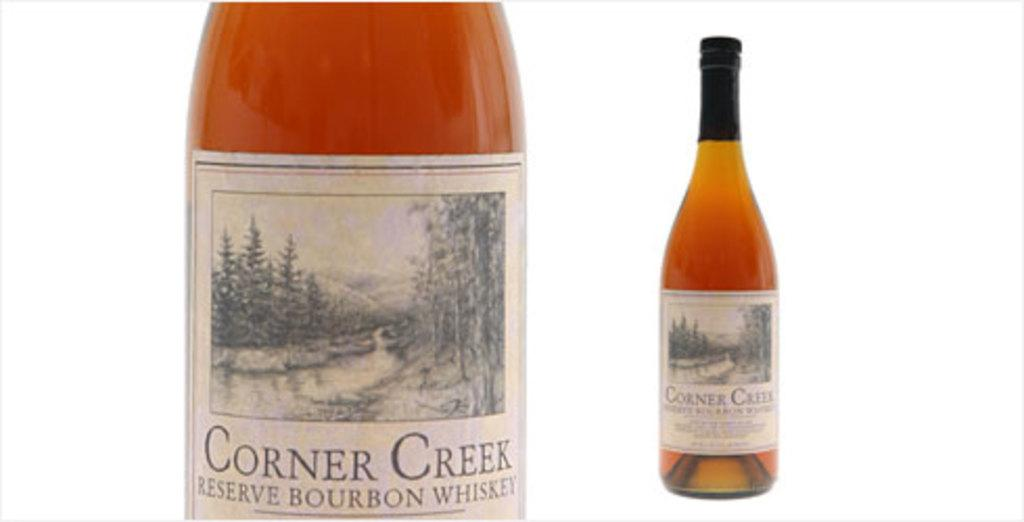Provide a one-sentence caption for the provided image. Two bottles of Corner Creek Reserve Bourbon Whisky on a white background. 